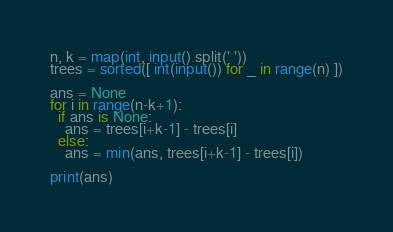Convert code to text. <code><loc_0><loc_0><loc_500><loc_500><_Python_>n, k = map(int, input().split(' '))
trees = sorted([ int(input()) for _ in range(n) ])

ans = None
for i in range(n-k+1):
  if ans is None:
    ans = trees[i+k-1] - trees[i]
  else:
    ans = min(ans, trees[i+k-1] - trees[i])
    
print(ans)
</code> 